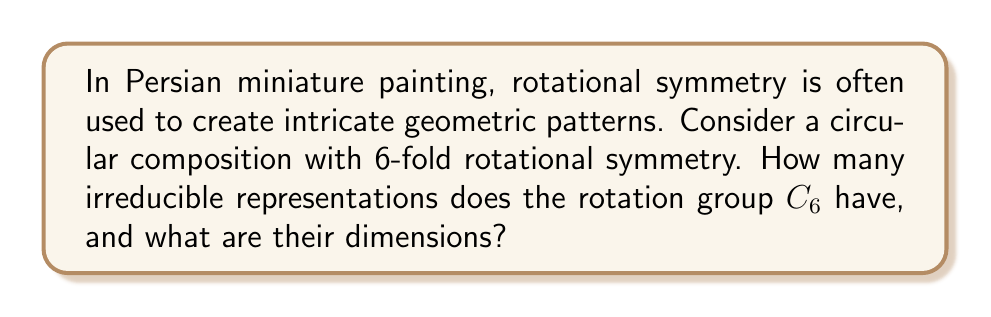Show me your answer to this math problem. To solve this problem, we'll follow these steps:

1) The rotation group $C_6$ is a cyclic group of order 6, generated by a rotation of $2\pi/6$.

2) For a cyclic group $C_n$, the number of irreducible representations is equal to the number of conjugacy classes, which is equal to the order of the group.

3) In this case, $C_6$ has 6 irreducible representations.

4) For cyclic groups, all irreducible representations are one-dimensional.

5) These representations can be described as:

   $$\rho_k(g) = e^{2\pi i k/6}$$

   where $k = 0, 1, 2, 3, 4, 5$ and $g$ is the generator of $C_6$.

6) In the context of Persian miniature painting, these representations correspond to how different elements in the composition transform under rotations of multiples of $60^\circ$.

7) For example:
   - $\rho_0$ represents elements invariant under all rotations
   - $\rho_1$ represents elements that return to their original position after a full $360^\circ$ rotation
   - $\rho_2$ represents elements that return to their original position after a $180^\circ$ rotation
   - and so on.
Answer: $C_6$ has 6 irreducible representations, all of dimension 1. 